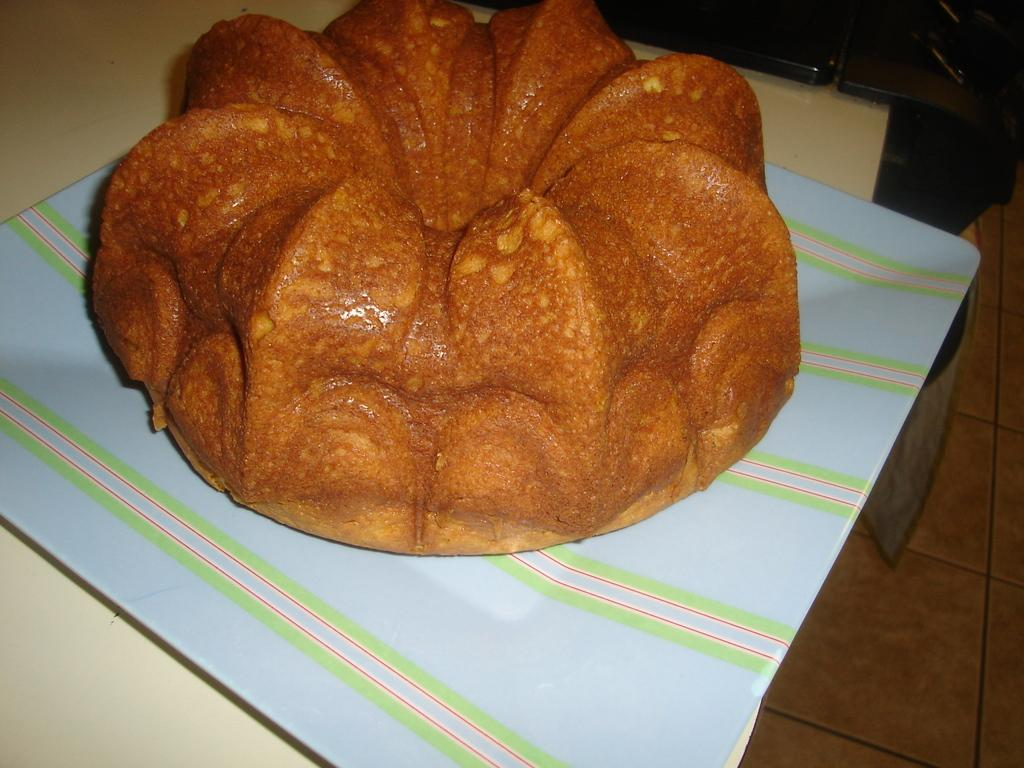What is the main object in the image? There is a bun piece in the image. Where is the bun piece placed? The bun piece is on a cloth. What is the cloth placed on? The cloth is over a table. What is the table resting on? The table is above a floor. What type of nose can be seen on the bun piece in the image? There is no nose present on the bun piece in the image. What color is the vase on the table in the image? There is no vase present on the table in the image. 